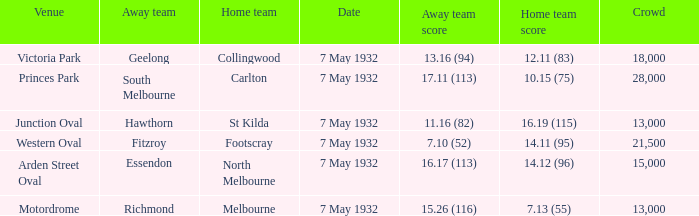Which home team has a Away team of hawthorn? St Kilda. 